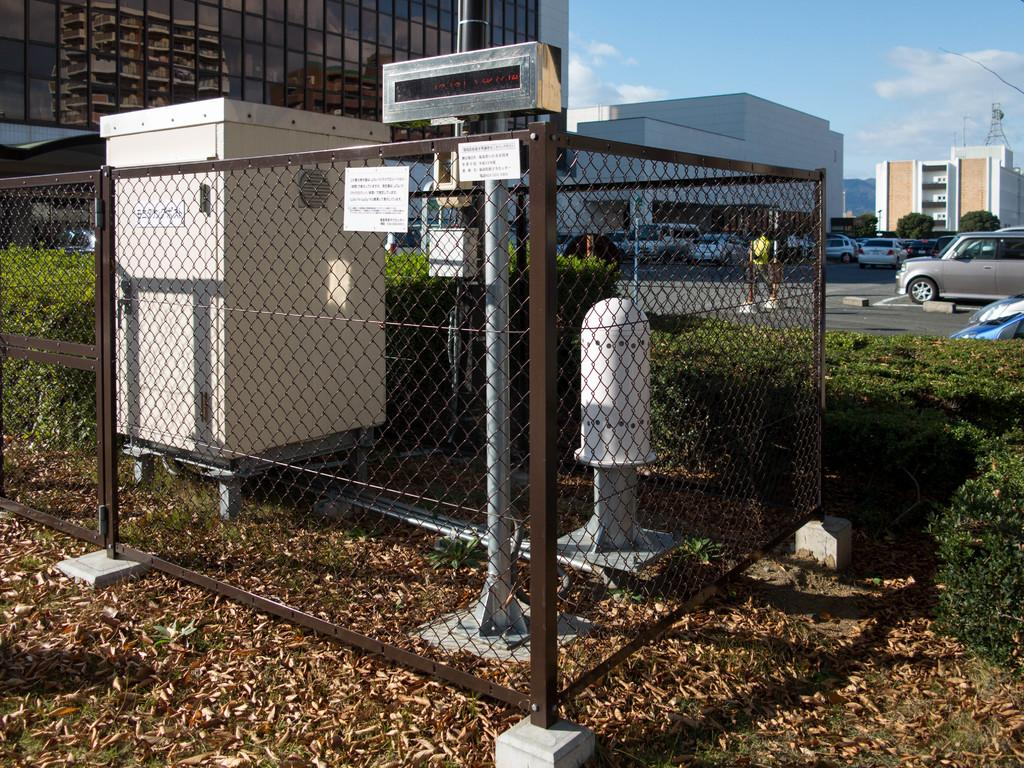What type of barrier can be seen in the image? There is a fence in the image. What vertical structure is present in the image? There is a pole in the image. What type of vegetation is visible in the image? Dry grass is visible in the image. What material is the metal object in the image made of? The metal object in the image is made of metal. What type of living organism is present in the image? A plant is present in the image. What part of the natural environment is visible in the image? The sky is visible in the image. How many structures can be seen in the image? There are many buildings in the image. What type of transportation is visible in the image? There are vehicles in the image. How many boys are playing with the stem in the image? There are no boys or stems present in the image. What type of request is being made by the boys in the image? There are no boys or requests present in the image. 